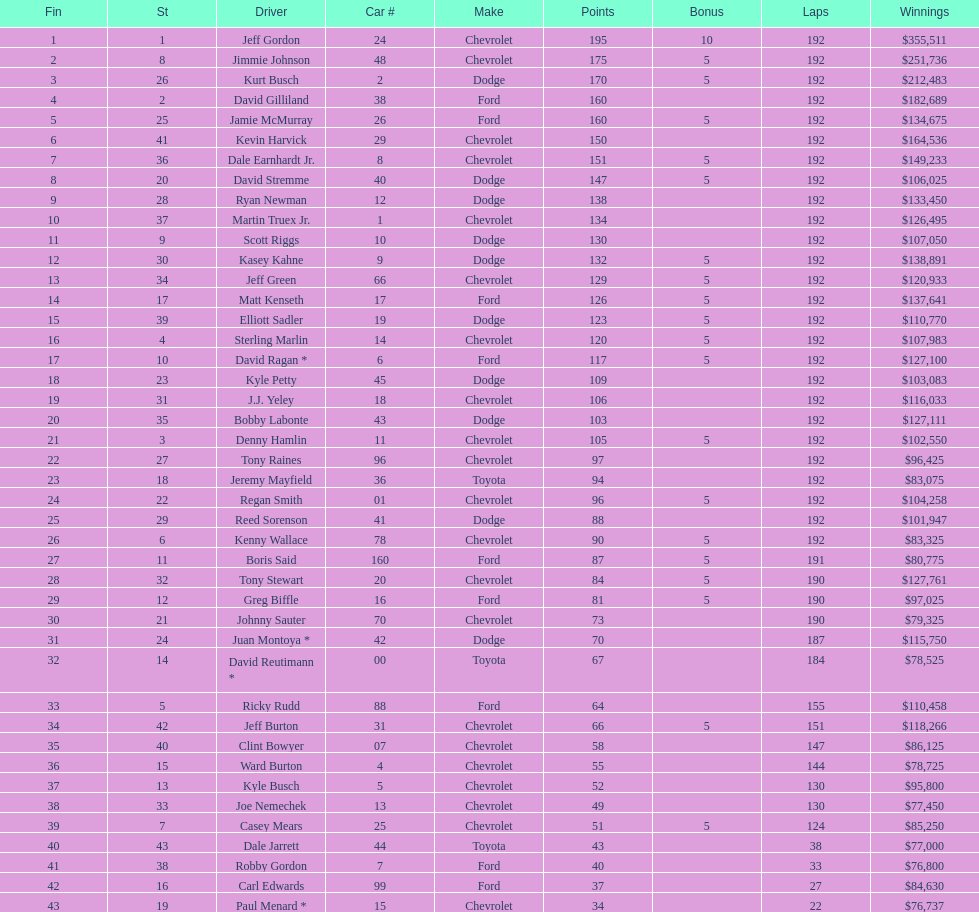What was jimmie johnson's winnings? $251,736. 